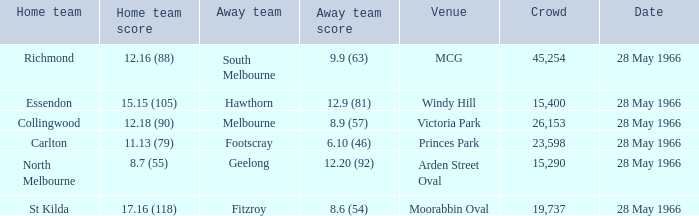6 (54)? 19737.0. 